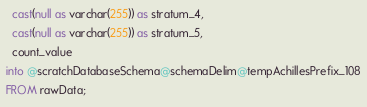<code> <loc_0><loc_0><loc_500><loc_500><_SQL_>  cast(null as varchar(255)) as stratum_4,
  cast(null as varchar(255)) as stratum_5,
  count_value
into @scratchDatabaseSchema@schemaDelim@tempAchillesPrefix_108
FROM rawData;
</code> 